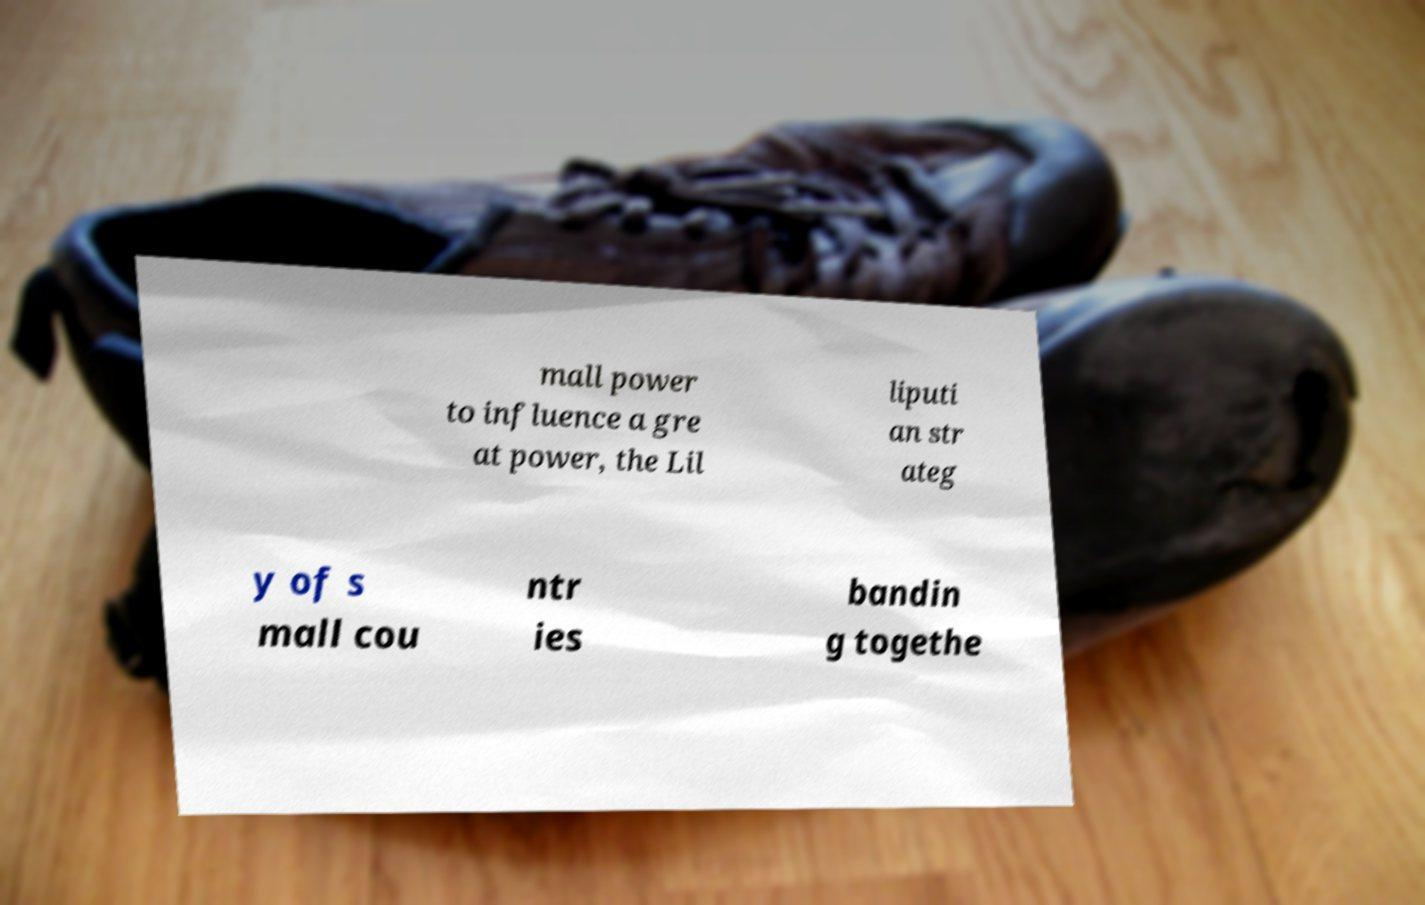For documentation purposes, I need the text within this image transcribed. Could you provide that? mall power to influence a gre at power, the Lil liputi an str ateg y of s mall cou ntr ies bandin g togethe 